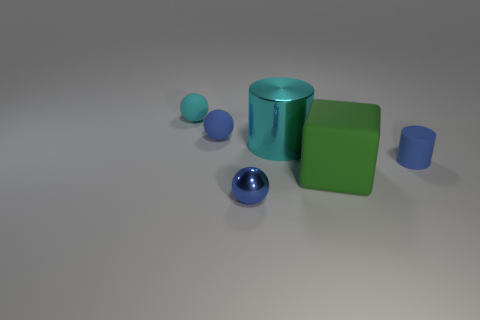What material is the small object that is to the right of the rubber cube?
Ensure brevity in your answer.  Rubber. What material is the object that is both in front of the tiny blue rubber cylinder and to the left of the large green thing?
Your answer should be compact. Metal. Is the size of the cyan object to the right of the metal sphere the same as the green matte object?
Provide a short and direct response. Yes. The small blue metallic thing is what shape?
Ensure brevity in your answer.  Sphere. How many other things have the same shape as the blue shiny thing?
Provide a short and direct response. 2. What number of small balls are both in front of the cyan metal object and behind the big cyan metal cylinder?
Give a very brief answer. 0. The matte cylinder has what color?
Ensure brevity in your answer.  Blue. Are there any things that have the same material as the cyan cylinder?
Give a very brief answer. Yes. There is a tiny matte object that is behind the tiny blue rubber object to the left of the tiny blue shiny ball; is there a small thing that is behind it?
Provide a succinct answer. No. Are there any big cylinders in front of the cyan shiny cylinder?
Your response must be concise. No. 